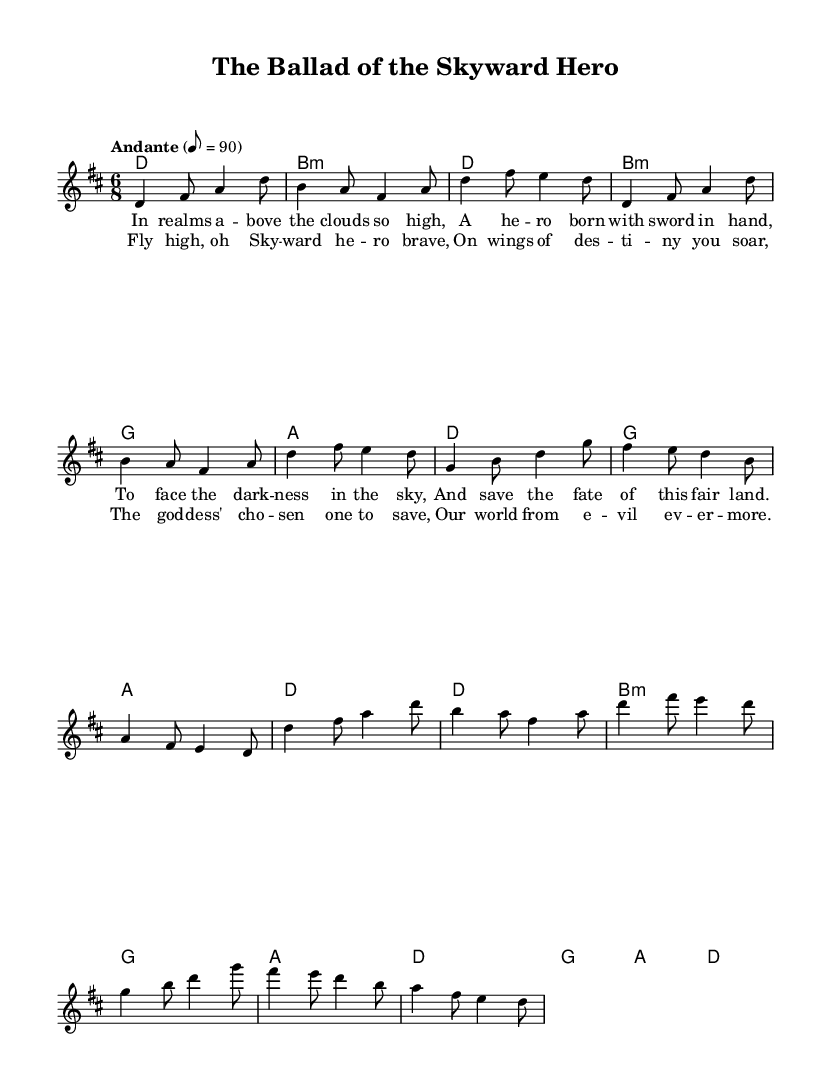What is the key signature of this music? The key signature can be identified from the beginning of the score where the key is specified. In this piece, the key is D major, which has two sharps (F# and C#).
Answer: D major What is the time signature of this piece? The time signature indicates how many beats are in each measure and can be found at the start of the music, noted as 6/8 in this case. This means there are six eighth note beats per measure.
Answer: 6/8 What is the tempo marking for this piece? The tempo marking is listed above the staff and describes the speed of the music. Here, it states "Andante" with a metronome marking of 8 = 90, which indicates a moderately slow tempo.
Answer: Andante 8 = 90 How many measures are in the verse section? To determine this, we count the measures in the indicated verse section from the music. The verse is made up of 6 measures.
Answer: 6 What is the musical form of the song? The form can be identified by observing how the sections are organized in the score. This piece follows a structure of Verse-Chorus, as indicated in the score sections.
Answer: Verse-Chorus What is the last note of the chorus? We can find the last note by looking at the chorus's notated melody in the sheet music, where the last note is marked as D.
Answer: D What themes are represented in the lyrics? The themes can be inferred from the lyrics written under the melody. The lyrics speak of heroism, destiny, and saving the world, embodying elements common in fantasy-inspired folk ballads.
Answer: Heroism, destiny, saving 